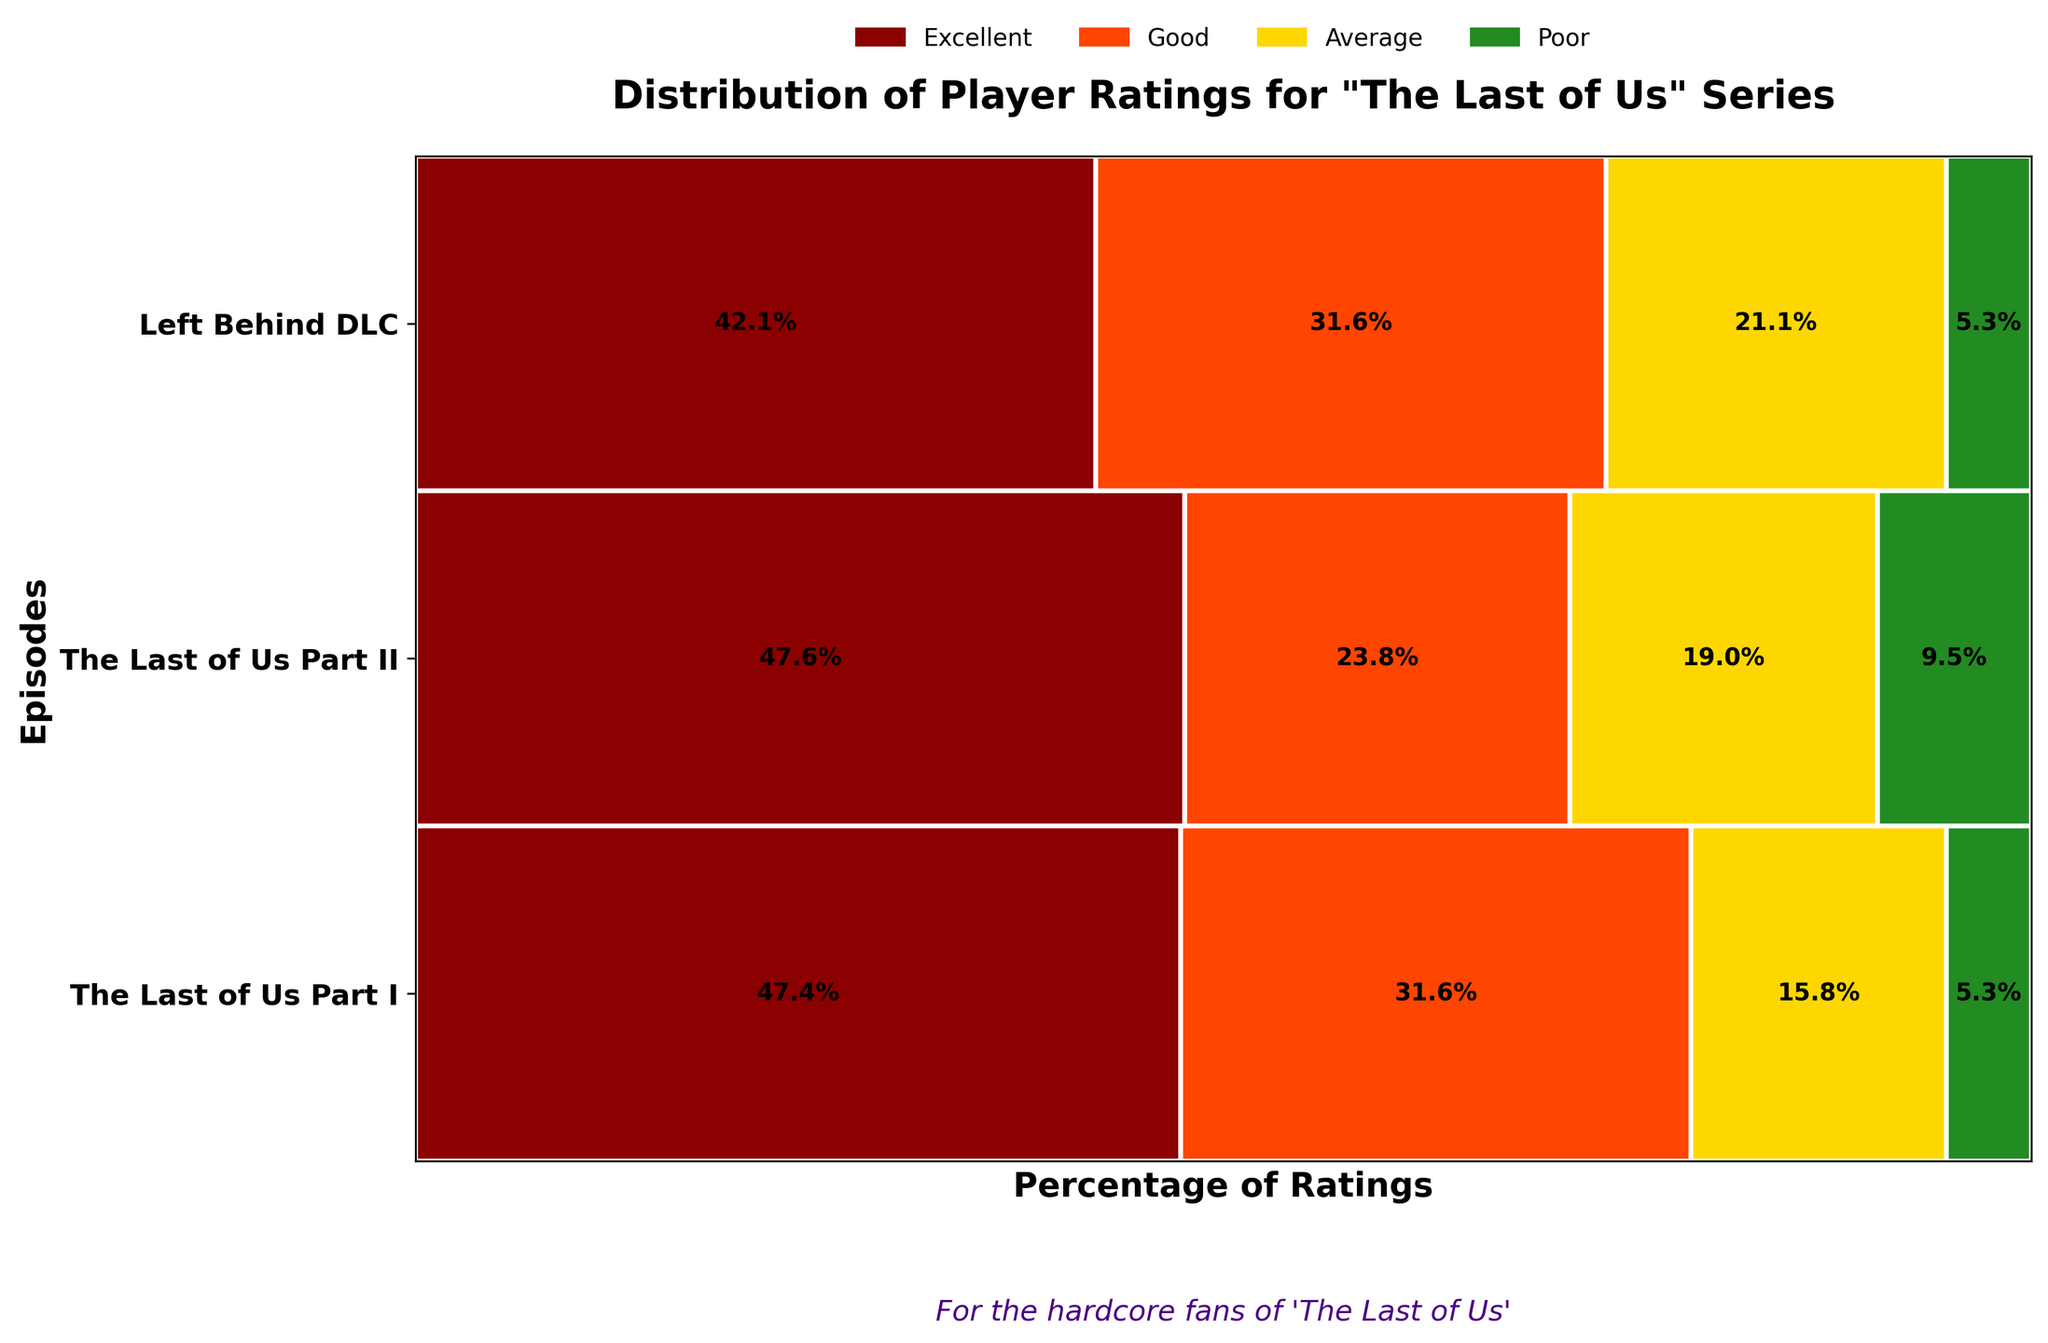What are the colors representing different ratings in the mosaic plot? The colors represent different ratings: dark red for 'Excellent', orange for 'Good', yellow for 'Average', and green for 'Poor'.
Answer: dark red, orange, yellow, green Which episode has the highest proportion of 'Excellent' ratings? In the mosaic plot, 'The Last of Us Part II' has the widest dark red bar, indicating the highest proportion of 'Excellent' ratings.
Answer: The Last of Us Part II How does the proportion of 'Poor' ratings compare between 'The Last of Us Part I' and the 'Left Behind DLC'? By comparing the sizes of the green bars, it is evident that 'The Last of Us Part I' has a larger proportion of 'Poor' ratings than the 'Left Behind DLC'.
Answer: The Last of Us Part I has a larger proportion Which episode has the smallest proportion of 'Average' ratings? The smallest yellow bar, representing 'Average' ratings, is found in 'Left Behind DLC'.
Answer: Left Behind DLC What is the combined proportion of 'Good' and 'Poor' ratings for 'The Last of Us Part II'? The orange and green bars together cover approximately half of the total width for 'The Last of Us Part II'. The orange bar (Good) is around 0.25 and the green bar (Poor) is around 0.125, combining to roughly 0.375.
Answer: 0.375 (or 37.5%) How does the proportion of 'Good' ratings in 'The Last of Us Part I' compare to 'The Last of Us Part II'? The orange bar representing 'Good' ratings for 'The Last of Us Part I' is wider than the corresponding bar for 'The Last of Us Part II'.
Answer: The Last of Us Part I has a higher proportion Which episode has the largest diversity in ratings? The episode with the most varied bar lengths for different ratings is 'The Last of Us Part I', indicating the largest diversity in ratings.
Answer: The Last of Us Part I What percentage of ratings for 'Left Behind DLC' is either 'Excellent' or 'Good'? Adding the percentages for 'Excellent' (dark red, around 39%) and 'Good' (orange, around 29%) for 'Left Behind DLC' sums to approximately 68%.
Answer: 68% In which episode is the difference between 'Excellent' and 'Poor' ratings the largest? The difference between the dark red and green bars is most pronounced in 'The Last of Us Part II'.
Answer: The Last of Us Part II For 'The Last of Us Part I', which rating category has the second-most ratings? By examining the widths, the orange bar ('Good') is the second widest after 'Excellent' (dark red) for 'The Last of Us Part I'.
Answer: Good 